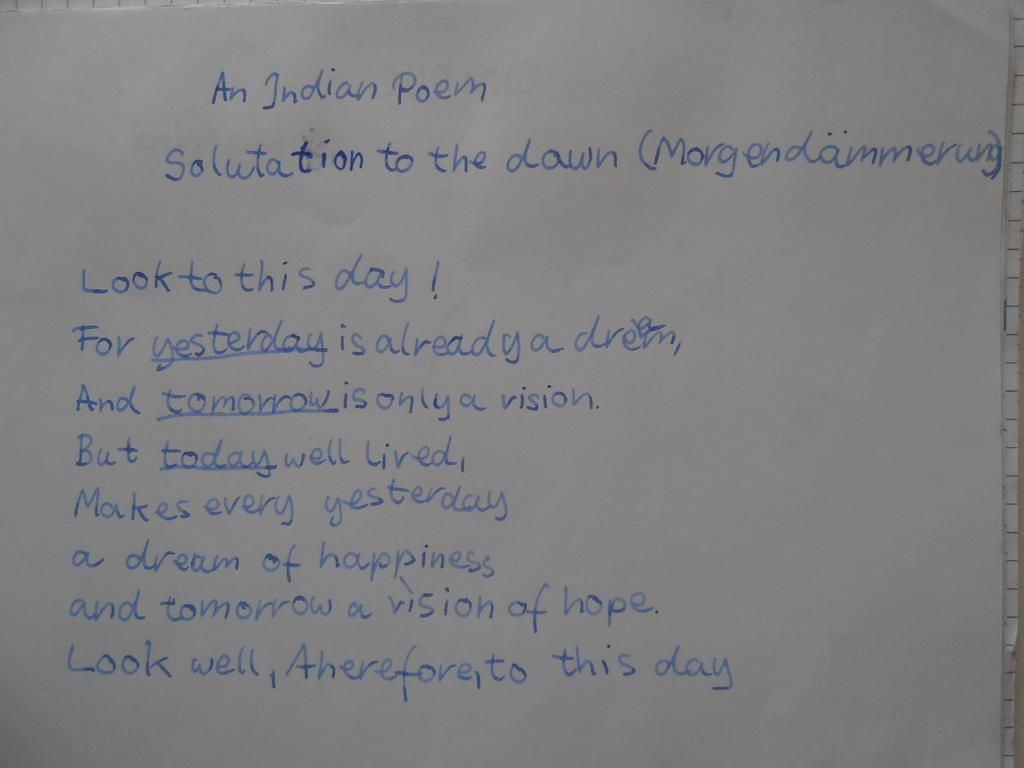<image>
Write a terse but informative summary of the picture. White board which starts with the words "An Indiam Poem". 